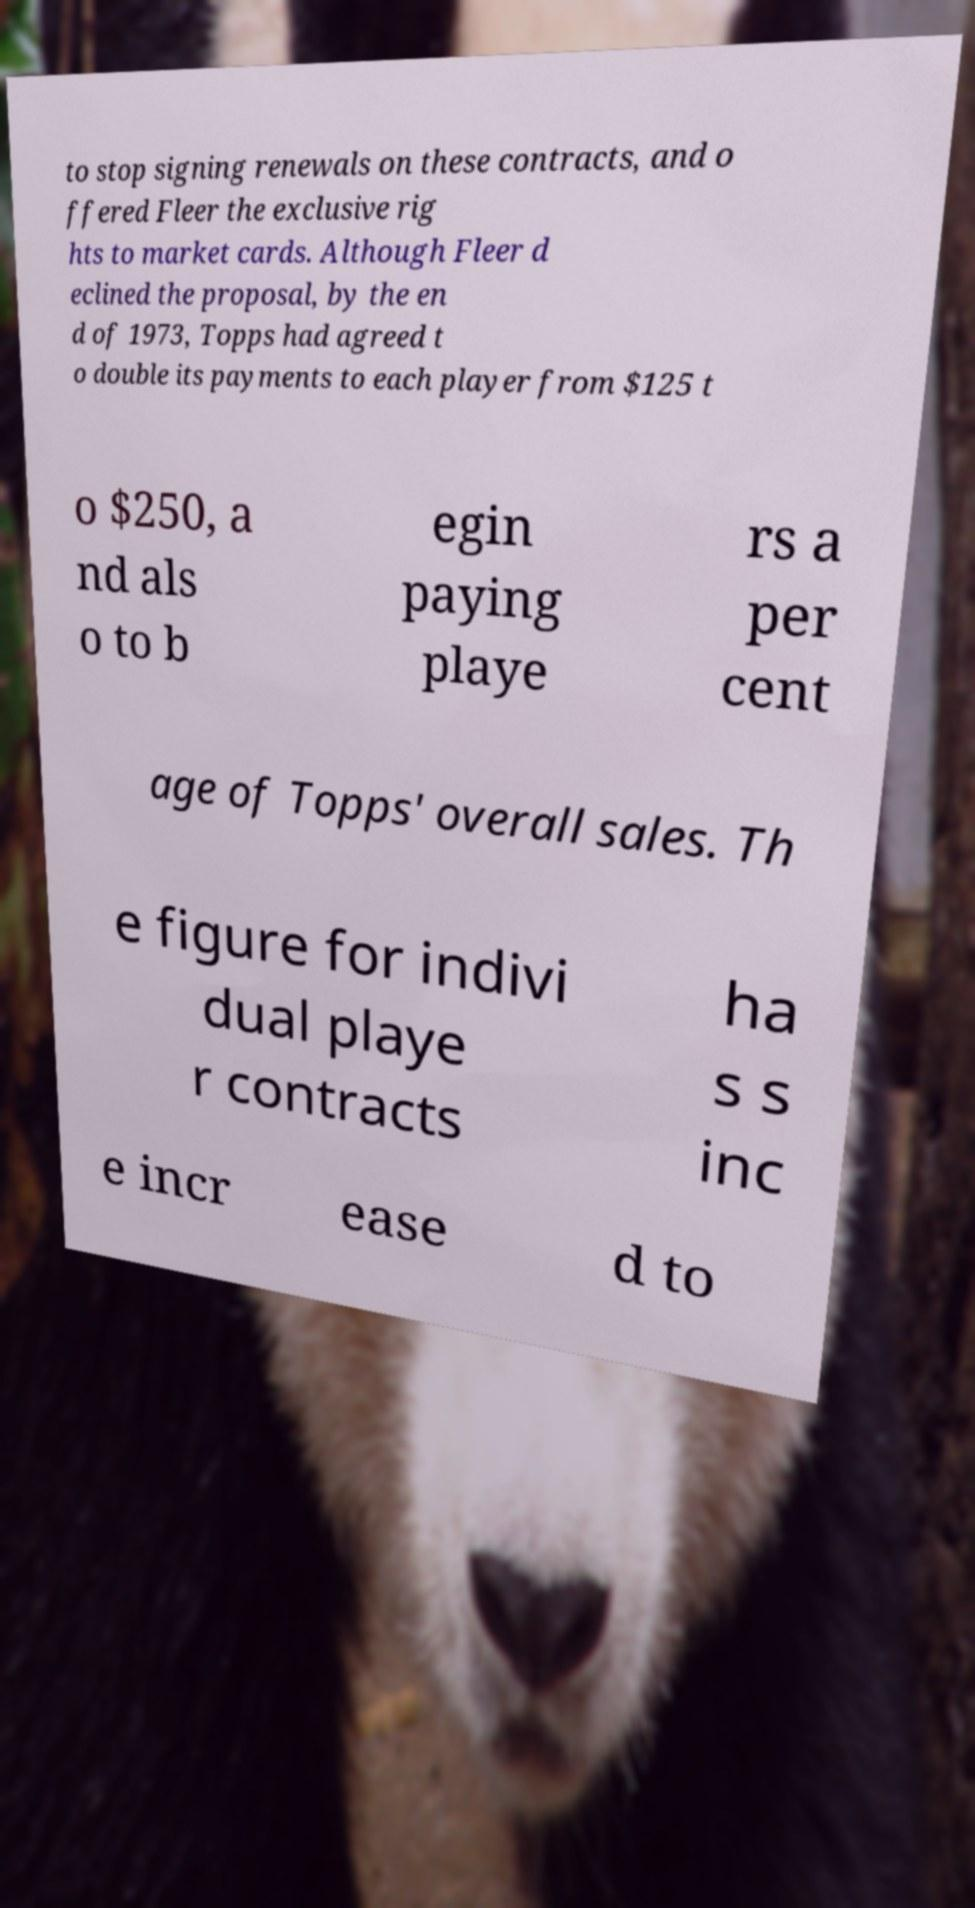Could you assist in decoding the text presented in this image and type it out clearly? to stop signing renewals on these contracts, and o ffered Fleer the exclusive rig hts to market cards. Although Fleer d eclined the proposal, by the en d of 1973, Topps had agreed t o double its payments to each player from $125 t o $250, a nd als o to b egin paying playe rs a per cent age of Topps' overall sales. Th e figure for indivi dual playe r contracts ha s s inc e incr ease d to 